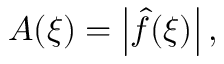Convert formula to latex. <formula><loc_0><loc_0><loc_500><loc_500>A ( \xi ) = \left | { \hat { f } } ( \xi ) \right | ,</formula> 